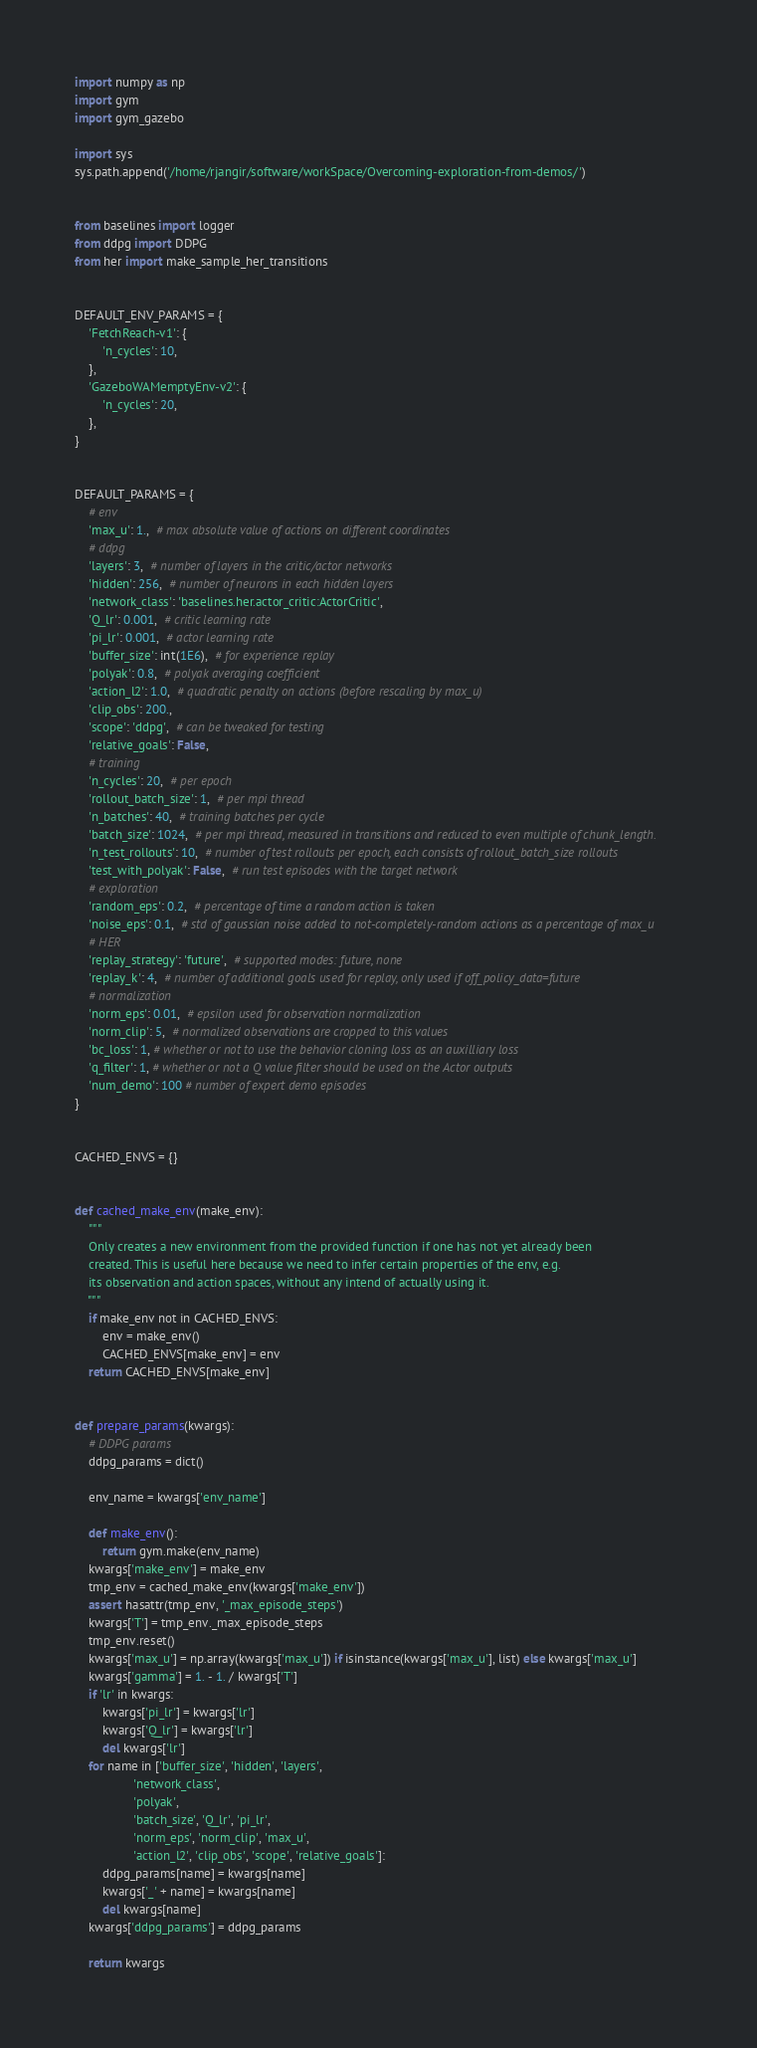Convert code to text. <code><loc_0><loc_0><loc_500><loc_500><_Python_>import numpy as np
import gym
import gym_gazebo

import sys
sys.path.append('/home/rjangir/software/workSpace/Overcoming-exploration-from-demos/')


from baselines import logger
from ddpg import DDPG
from her import make_sample_her_transitions


DEFAULT_ENV_PARAMS = {
    'FetchReach-v1': {
        'n_cycles': 10,
    },
    'GazeboWAMemptyEnv-v2': {
        'n_cycles': 20,
    },
}


DEFAULT_PARAMS = {
    # env
    'max_u': 1.,  # max absolute value of actions on different coordinates
    # ddpg
    'layers': 3,  # number of layers in the critic/actor networks
    'hidden': 256,  # number of neurons in each hidden layers
    'network_class': 'baselines.her.actor_critic:ActorCritic',
    'Q_lr': 0.001,  # critic learning rate
    'pi_lr': 0.001,  # actor learning rate
    'buffer_size': int(1E6),  # for experience replay
    'polyak': 0.8,  # polyak averaging coefficient
    'action_l2': 1.0,  # quadratic penalty on actions (before rescaling by max_u)
    'clip_obs': 200.,
    'scope': 'ddpg',  # can be tweaked for testing
    'relative_goals': False,
    # training
    'n_cycles': 20,  # per epoch
    'rollout_batch_size': 1,  # per mpi thread
    'n_batches': 40,  # training batches per cycle
    'batch_size': 1024,  # per mpi thread, measured in transitions and reduced to even multiple of chunk_length.
    'n_test_rollouts': 10,  # number of test rollouts per epoch, each consists of rollout_batch_size rollouts
    'test_with_polyak': False,  # run test episodes with the target network
    # exploration
    'random_eps': 0.2,  # percentage of time a random action is taken
    'noise_eps': 0.1,  # std of gaussian noise added to not-completely-random actions as a percentage of max_u
    # HER
    'replay_strategy': 'future',  # supported modes: future, none
    'replay_k': 4,  # number of additional goals used for replay, only used if off_policy_data=future
    # normalization
    'norm_eps': 0.01,  # epsilon used for observation normalization
    'norm_clip': 5,  # normalized observations are cropped to this values
    'bc_loss': 1, # whether or not to use the behavior cloning loss as an auxilliary loss
    'q_filter': 1, # whether or not a Q value filter should be used on the Actor outputs
    'num_demo': 100 # number of expert demo episodes
}


CACHED_ENVS = {}


def cached_make_env(make_env):
    """
    Only creates a new environment from the provided function if one has not yet already been
    created. This is useful here because we need to infer certain properties of the env, e.g.
    its observation and action spaces, without any intend of actually using it.
    """
    if make_env not in CACHED_ENVS:
        env = make_env()
        CACHED_ENVS[make_env] = env
    return CACHED_ENVS[make_env]


def prepare_params(kwargs):
    # DDPG params
    ddpg_params = dict()

    env_name = kwargs['env_name']

    def make_env():
        return gym.make(env_name)
    kwargs['make_env'] = make_env
    tmp_env = cached_make_env(kwargs['make_env'])
    assert hasattr(tmp_env, '_max_episode_steps')
    kwargs['T'] = tmp_env._max_episode_steps
    tmp_env.reset()
    kwargs['max_u'] = np.array(kwargs['max_u']) if isinstance(kwargs['max_u'], list) else kwargs['max_u']
    kwargs['gamma'] = 1. - 1. / kwargs['T']
    if 'lr' in kwargs:
        kwargs['pi_lr'] = kwargs['lr']
        kwargs['Q_lr'] = kwargs['lr']
        del kwargs['lr']
    for name in ['buffer_size', 'hidden', 'layers',
                 'network_class',
                 'polyak',
                 'batch_size', 'Q_lr', 'pi_lr',
                 'norm_eps', 'norm_clip', 'max_u',
                 'action_l2', 'clip_obs', 'scope', 'relative_goals']:
        ddpg_params[name] = kwargs[name]
        kwargs['_' + name] = kwargs[name]
        del kwargs[name]
    kwargs['ddpg_params'] = ddpg_params

    return kwargs

</code> 